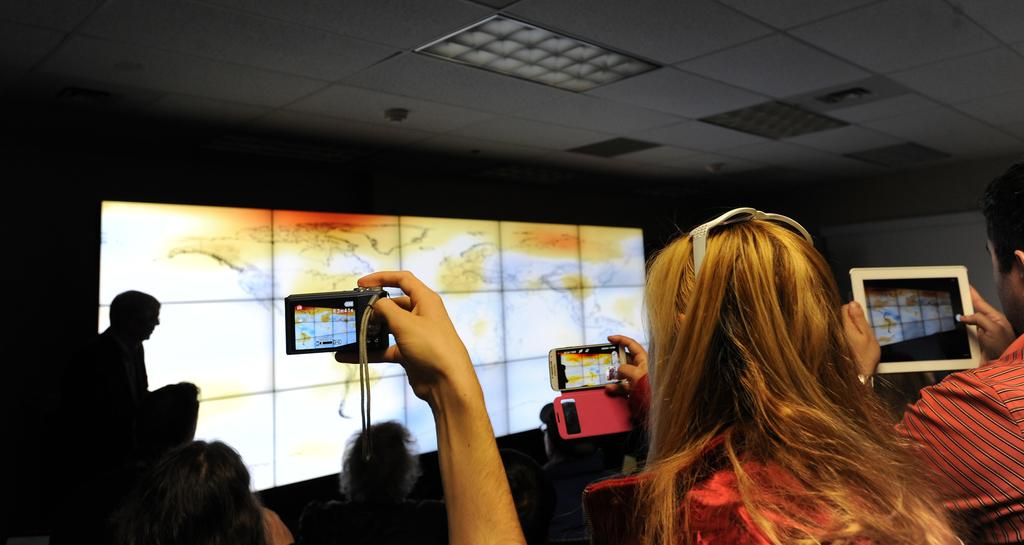What is on the board in the image? There is a designed screen on a board in the image. Who is present in the image? There are people in the image. What are the people doing in the image? The people are taking pictures. What type of pipe can be seen in the image? There is no pipe present in the image. What is inside the basket in the image? There is no basket present in the image. 